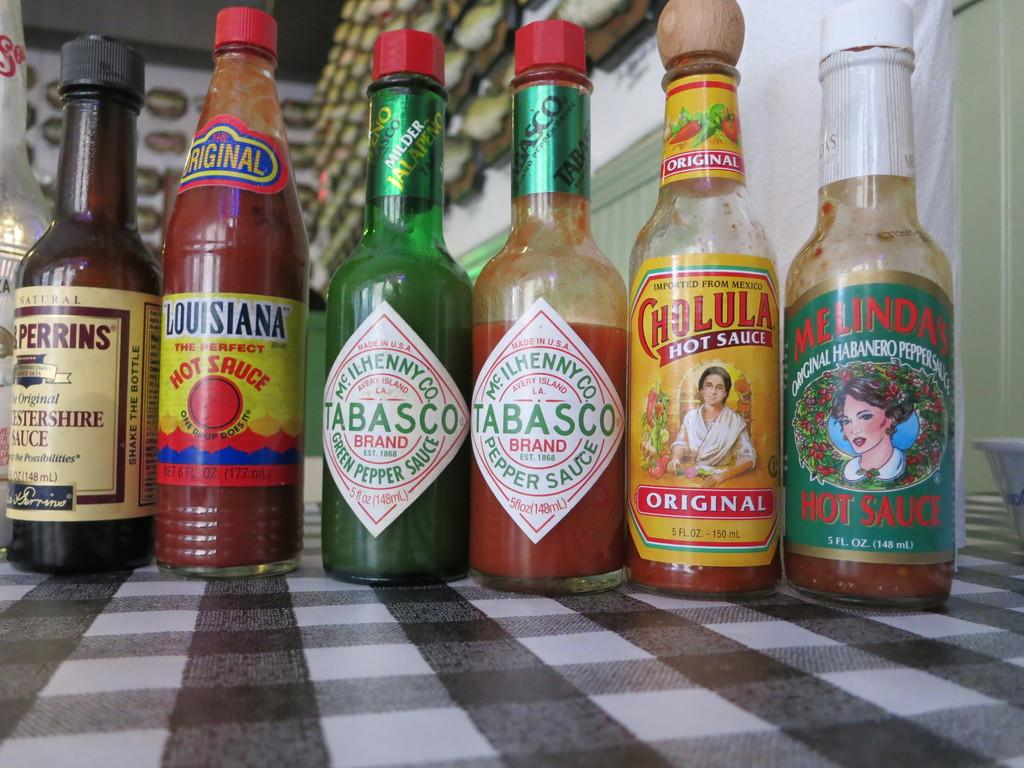<image>
Share a concise interpretation of the image provided. Six bottles of sauce are on a checkerboard surface, two of which are Tabasco. 